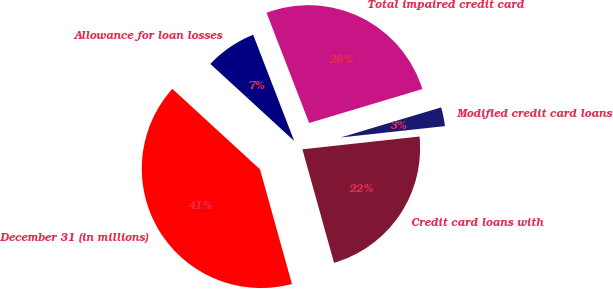Convert chart. <chart><loc_0><loc_0><loc_500><loc_500><pie_chart><fcel>December 31 (in millions)<fcel>Credit card loans with<fcel>Modified credit card loans<fcel>Total impaired credit card<fcel>Allowance for loan losses<nl><fcel>41.15%<fcel>22.41%<fcel>2.9%<fcel>26.24%<fcel>7.31%<nl></chart> 